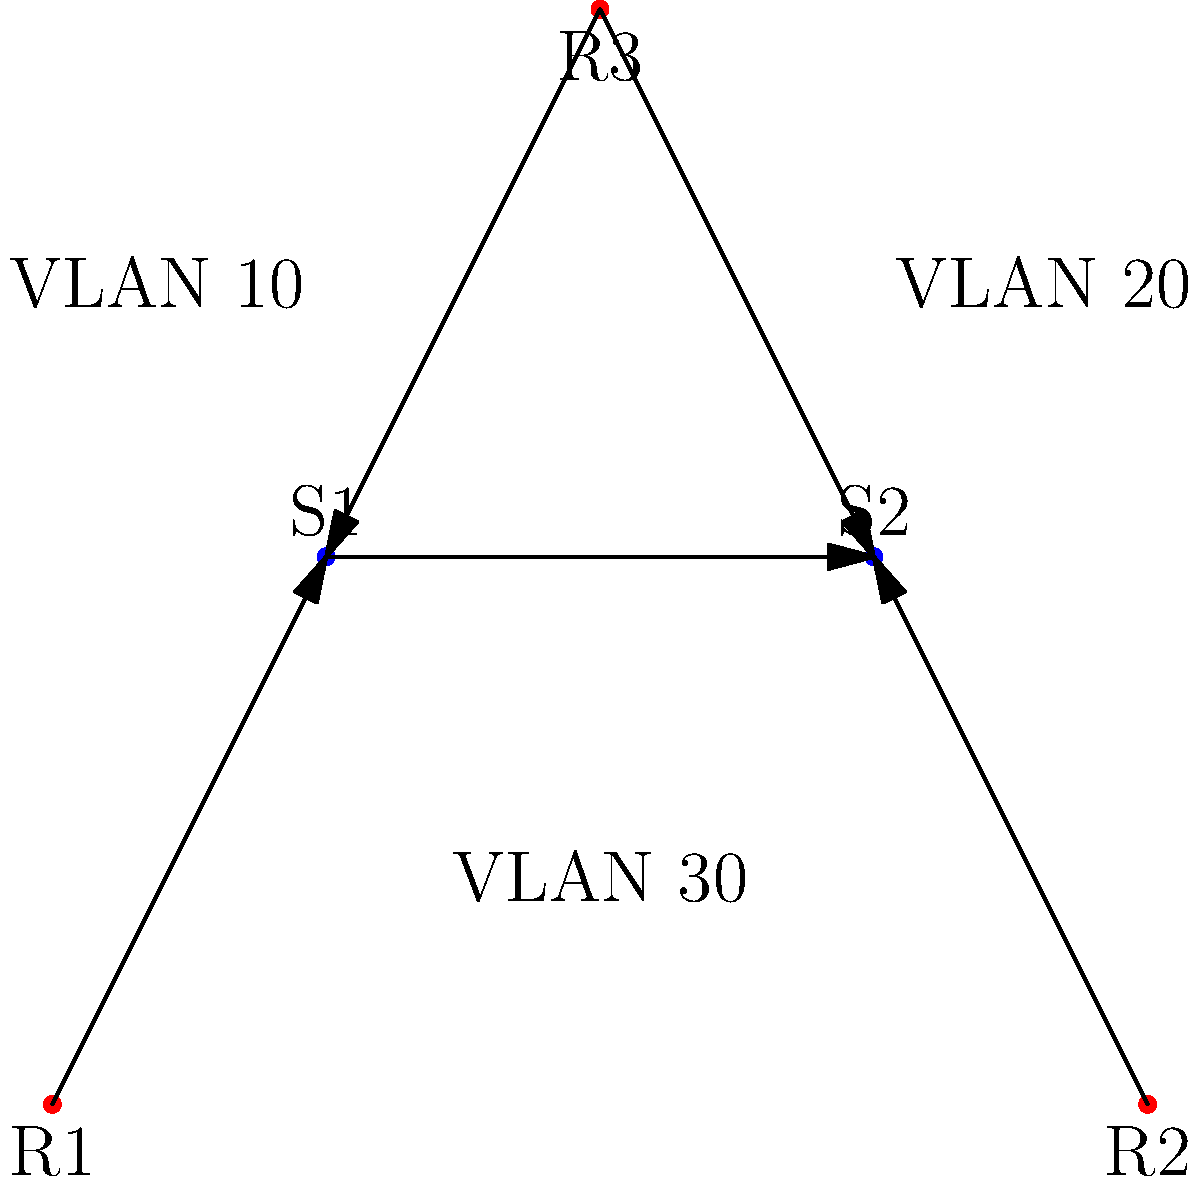In the given enterprise network topology, you need to implement VLANs and subnets to improve network segmentation and performance. The network consists of 3 routers (R1, R2, R3) and 2 switches (S1, S2). Three VLANs (10, 20, 30) need to be configured. How many subnets should be created to ensure proper VLAN communication and inter-VLAN routing? To determine the number of subnets needed, let's follow these steps:

1. Analyze the network topology:
   - 3 routers (R1, R2, R3)
   - 2 switches (S1, S2)
   - 3 VLANs (10, 20, 30)

2. Consider VLAN requirements:
   - Each VLAN requires its own subnet for internal communication.
   - Total subnets for VLANs: 3

3. Router-to-router links:
   - R1 to R2 (via S1-S2): 1 subnet
   - R1 to R3: 1 subnet
   - R2 to R3: 1 subnet
   - Total subnets for router links: 3

4. Router-to-switch links:
   - R1 to S1: 1 subnet
   - R2 to S2: 1 subnet
   - R3 to S1: 1 subnet
   - R3 to S2: 1 subnet
   - Total subnets for router-switch links: 4

5. Sum up all required subnets:
   - VLAN subnets: 3
   - Router-to-router subnets: 3
   - Router-to-switch subnets: 4
   - Total subnets: 3 + 3 + 4 = 10

Therefore, to ensure proper VLAN communication and inter-VLAN routing in this enterprise network topology, 10 subnets should be created.
Answer: 10 subnets 